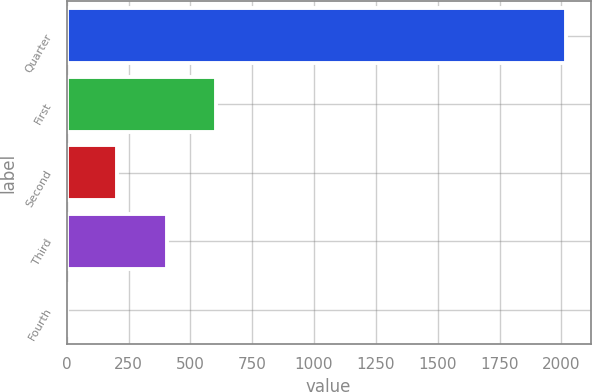<chart> <loc_0><loc_0><loc_500><loc_500><bar_chart><fcel>Quarter<fcel>First<fcel>Second<fcel>Third<fcel>Fourth<nl><fcel>2017<fcel>605.46<fcel>202.16<fcel>403.81<fcel>0.51<nl></chart> 